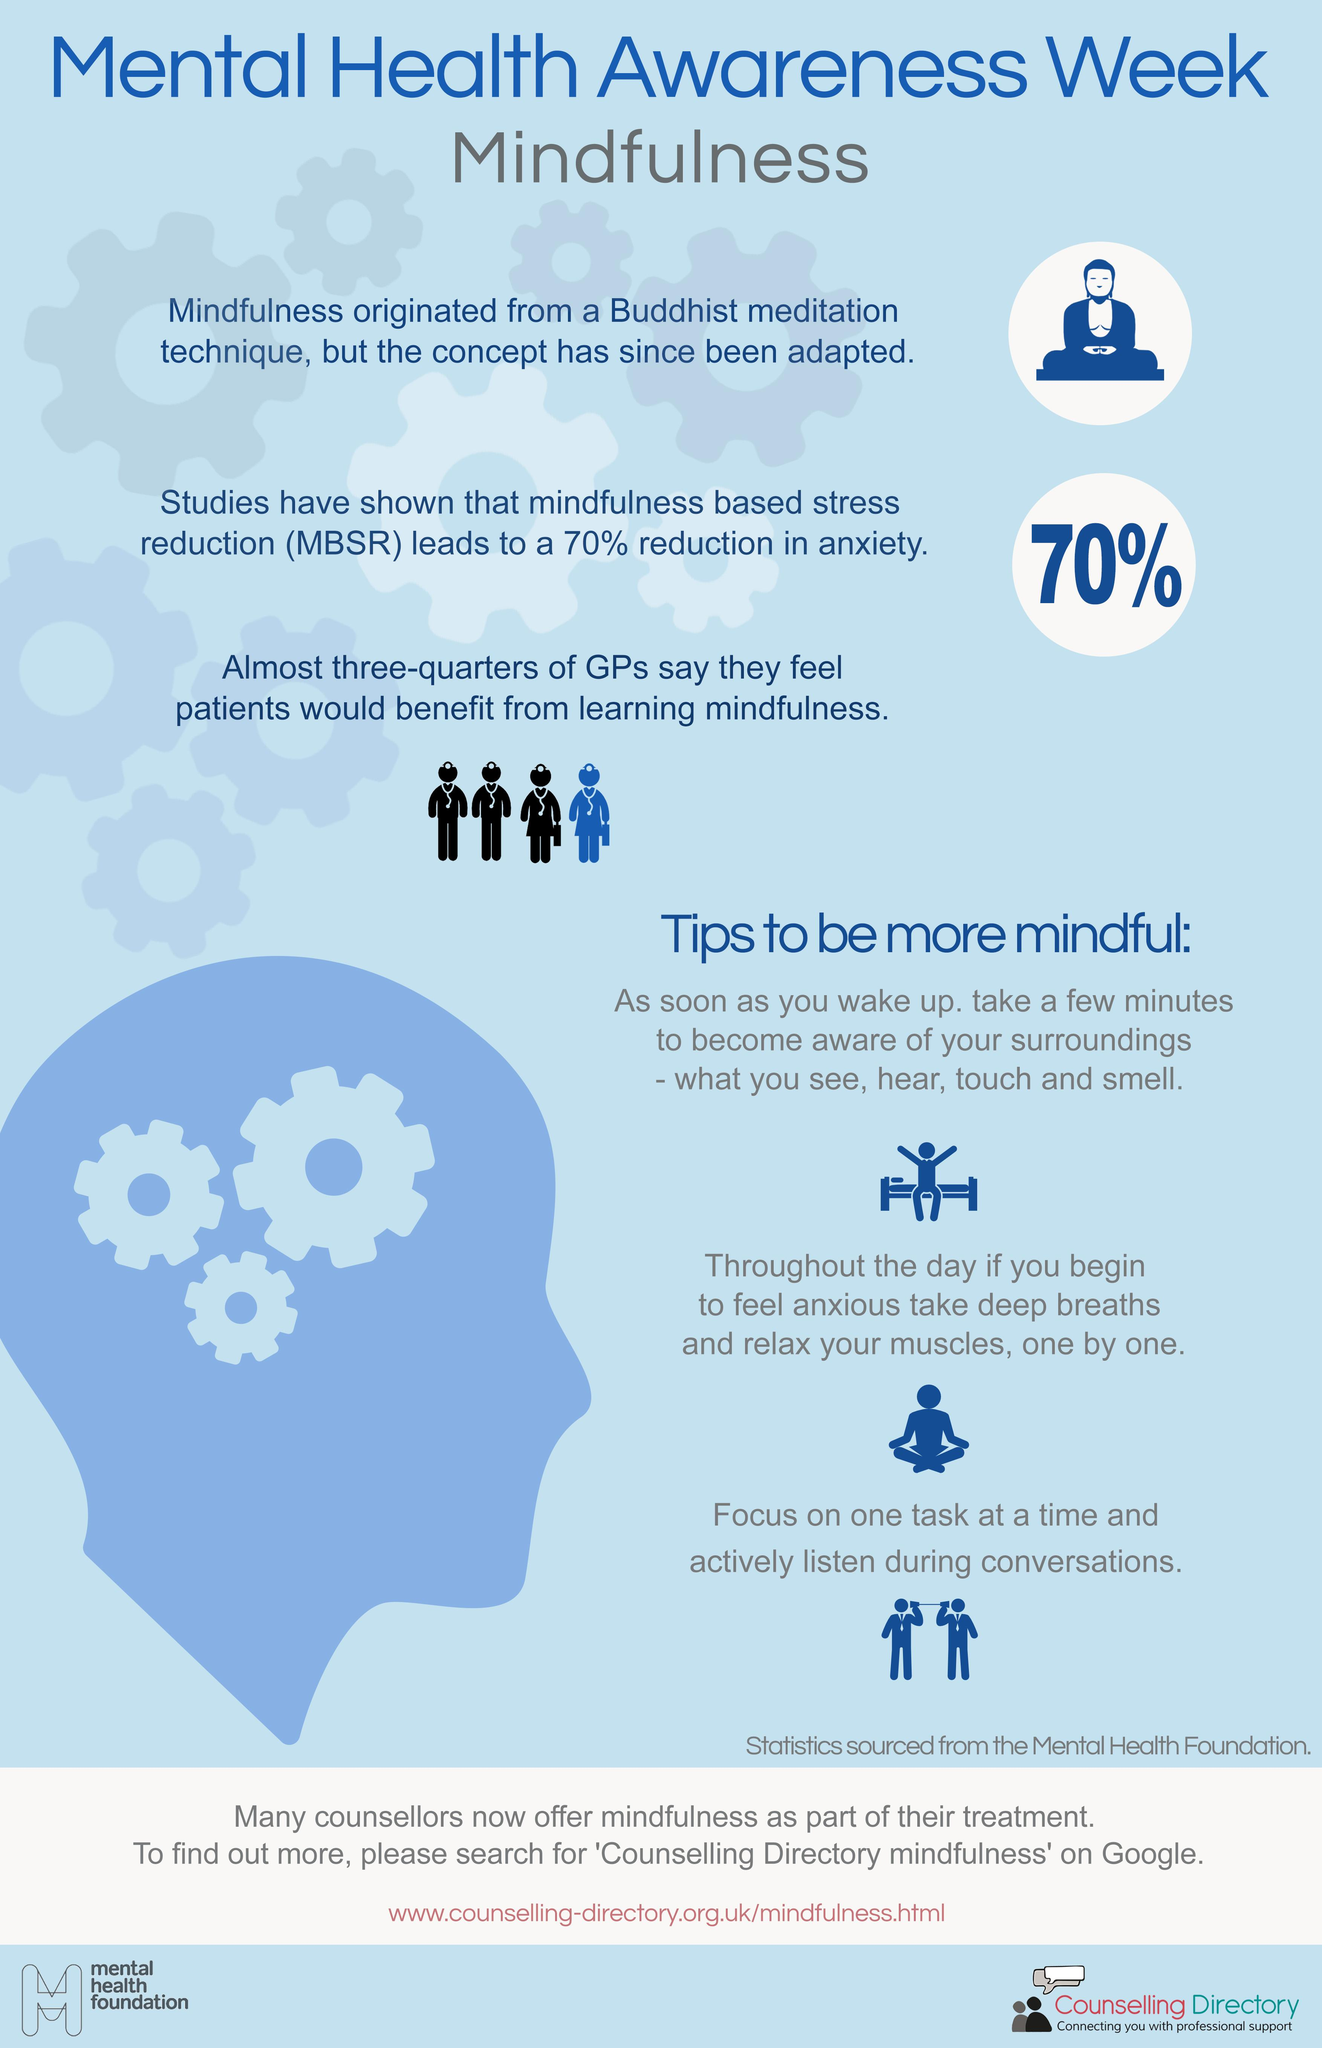Indicate a few pertinent items in this graphic. Seventy-five percent of GPs believe that patients will benefit from mindfulness. Mindfulness originates from Buddhism. The images depicting general practitioners show a disproportionate number of black individuals at 3. A survey of four GPs found that three of them believe that their patients will not benefit from mindfulness. 